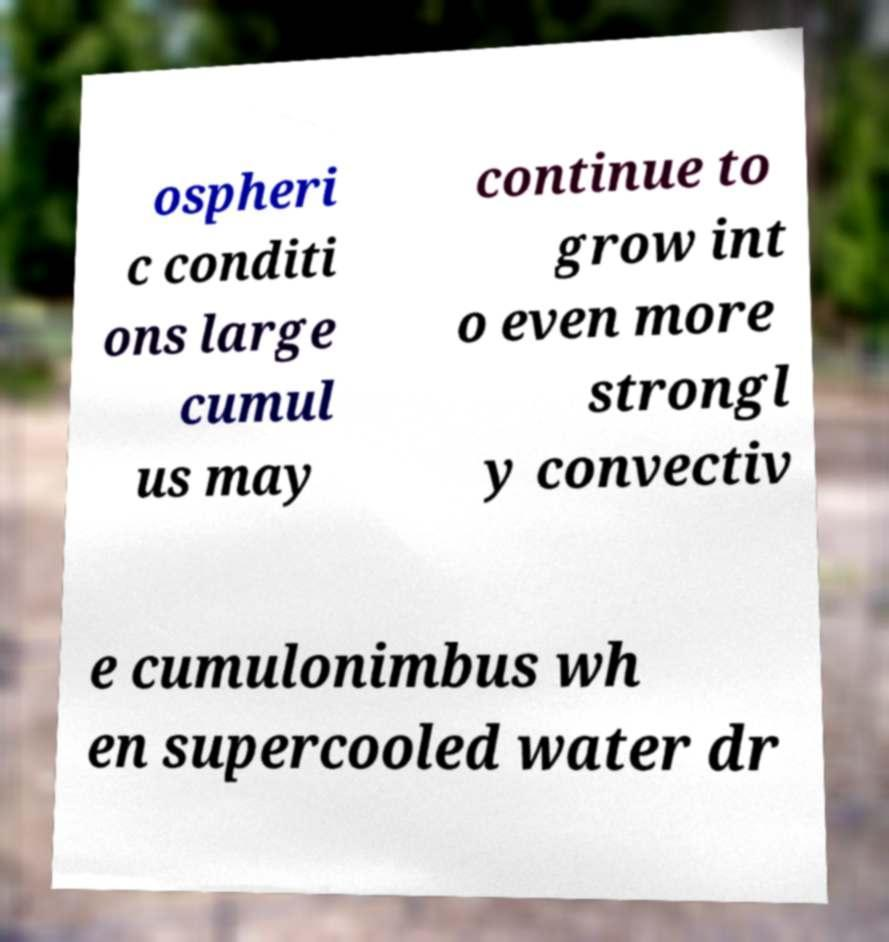Could you assist in decoding the text presented in this image and type it out clearly? ospheri c conditi ons large cumul us may continue to grow int o even more strongl y convectiv e cumulonimbus wh en supercooled water dr 